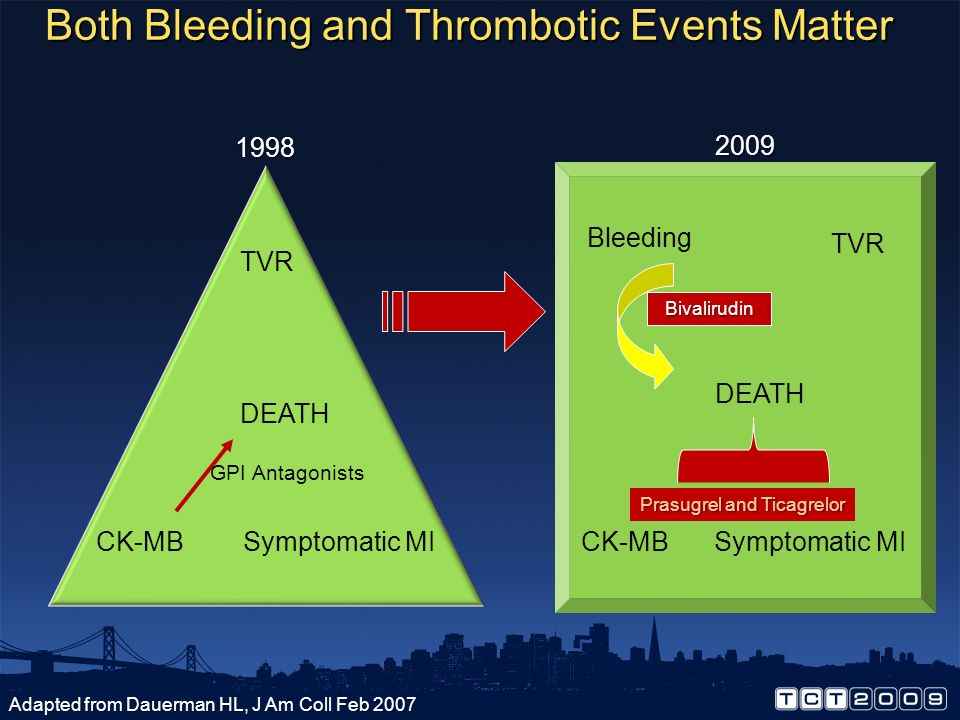Imagine this chart displayed in a futuristic medical conference. What might doctors discuss regarding the evolution of treatments? In a futuristic medical conference, observing this chart, doctors might engage in discussions about the critical transformation in cardiovascular treatment strategies over the years. They would elaborate on how the integration of bleeding risk management alongside thrombotic event prevention marked a significant milestone in patient safety. The room might buzz with excitement over the new era of personalized medicine where treatments could be precisely tailored to individual genetic profiles, anticipating and mitigating side effects before they occur. Moreover, they might explore how artificial intelligence and big data analytics aid in continuously refining treatment algorithms, ensuring optimal outcomes while minimizing complications. Considering the advancements from 1998 to 2009, what could be the potential medical advancements by 2050? By 2050, potential medical advancements could revolutionize cardiovascular care beyond our current imagination. We could anticipate the development of bioengineered blood vessels and tissues that more efficiently integrate with the human body, reducing the need for revascularization. Nanotechnology might facilitate the targeted delivery of medications, directly to the affected cells, thereby minimizing systemic side effects. There could also be widespread use of AI-driven diagnostics and treatment planning, providing real-time adjustments based on patient responses. Innovations in gene therapy and regenerative medicine may offer cure-centric approaches rather than merely managing conditions, fundamentally altering the landscape of cardiovascular medicine. If you could blend science fiction with medical advancements, how might treatments evolve in a world where teleportation exists? In a world where teleportation exists, medical advancements could push the boundaries of imagination. Teleportation could theoretically enable instant repair or replacement of damaged organs and tissues at the molecular level. Imagine teleportation devices programmed to scan, identify, and rectify internal bodily issues instantaneously, leading to immediate healing of injuries or diseases without invasive procedures. Nanobots equipped with teleportation capabilities might travel within the bloodstream, teleporting diseased cells out and healthy cells in. Teleportation-augmented gene therapy could modify genetic defects in an instant, vastly improving longevity and quality of life. This confluence of technologies could usher in an era where illnesses are swiftly and decisively addressed, minimizing patient discomfort and recovery time. 